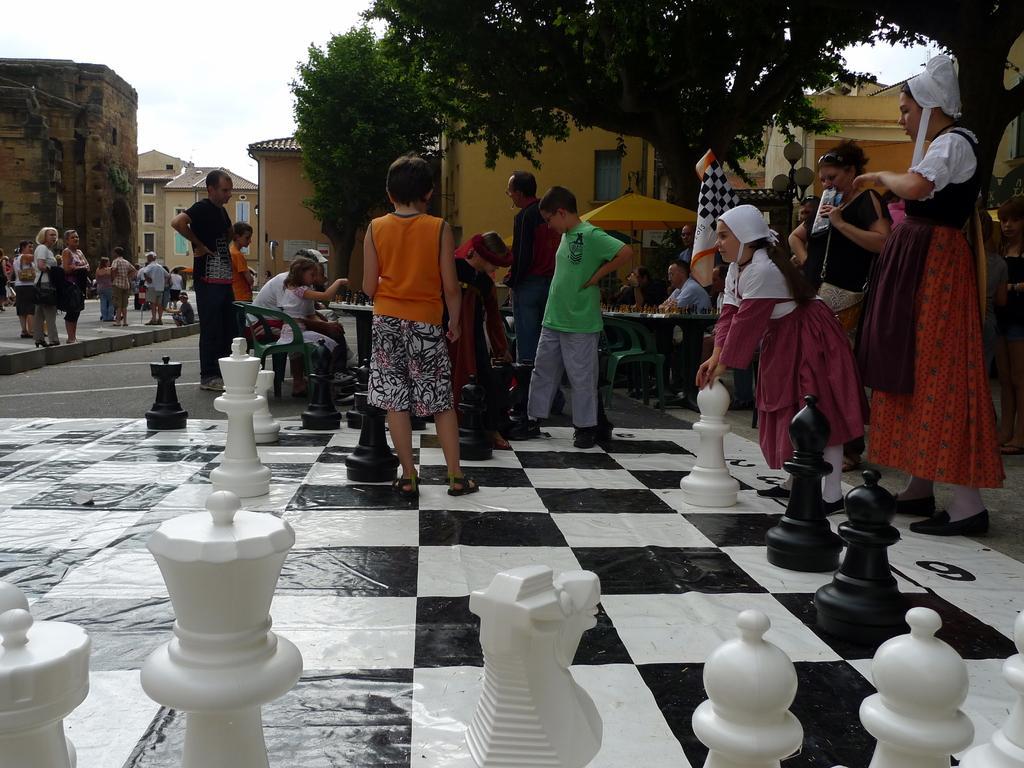Please provide a concise description of this image. In the picture we can some children and a people standing on the road and we can also see some painting on the floor like a chess board. In the background we can see some buildings, houses, trees, and sky. 